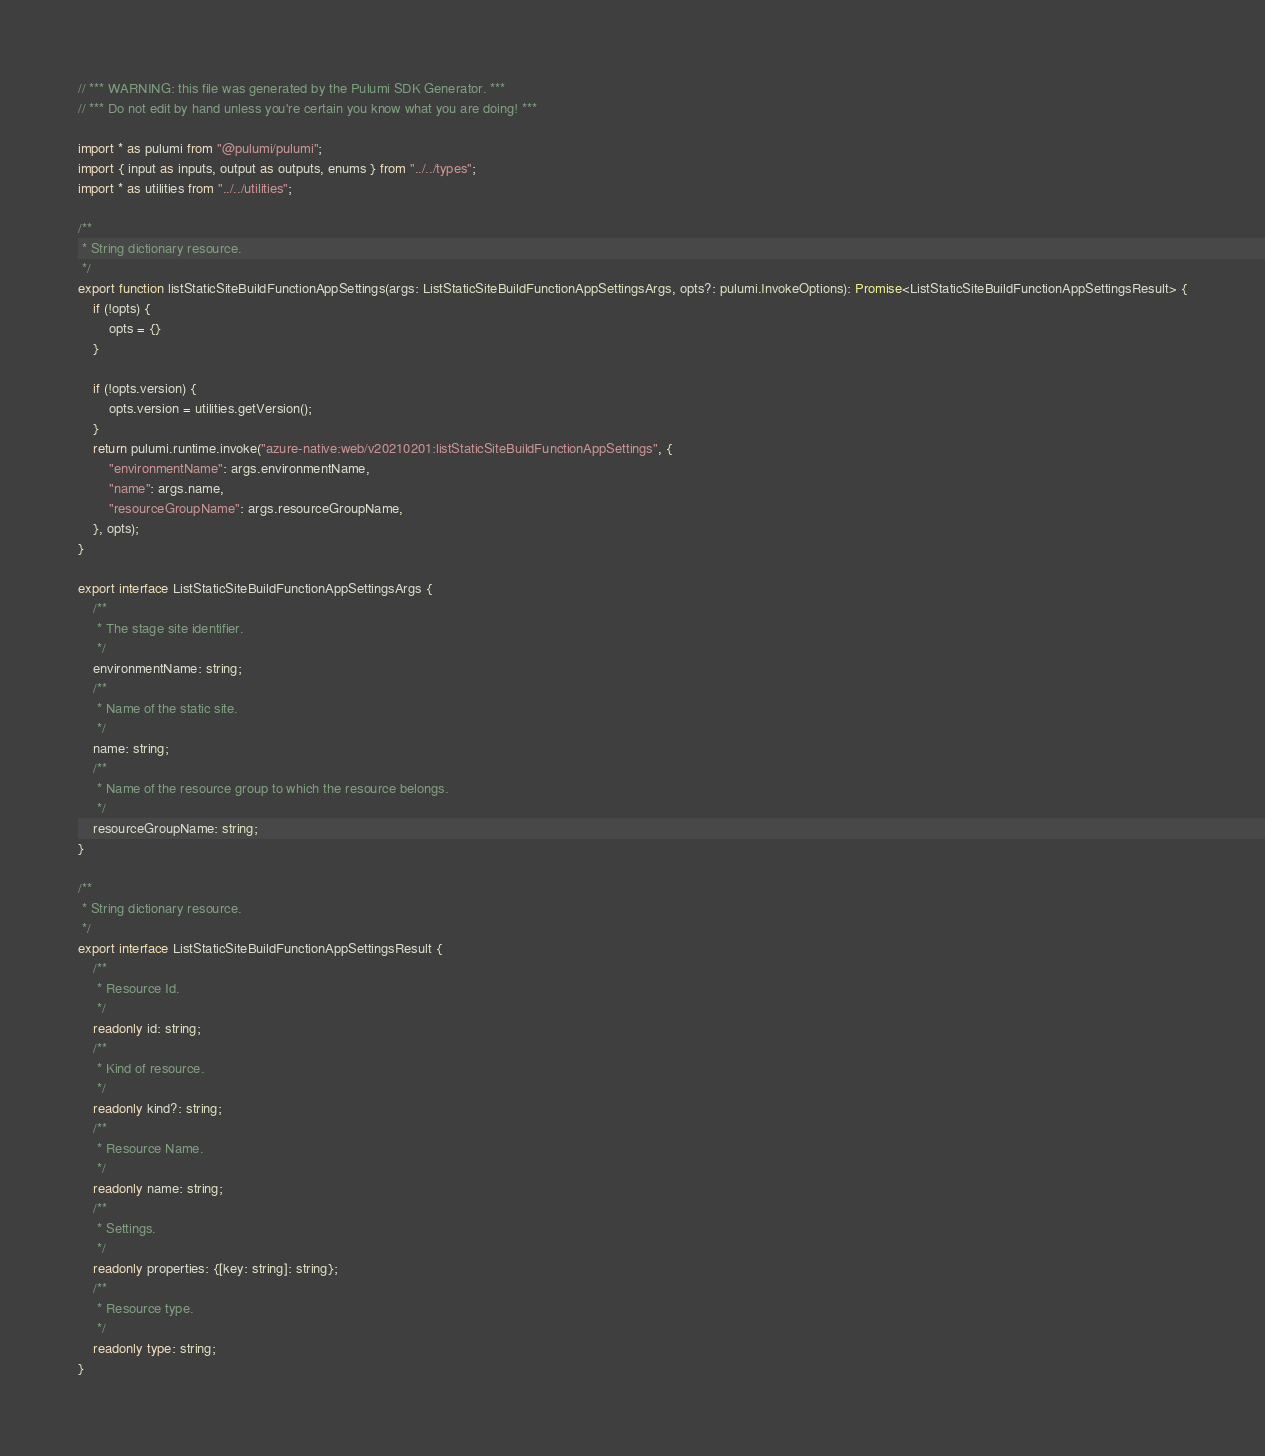Convert code to text. <code><loc_0><loc_0><loc_500><loc_500><_TypeScript_>// *** WARNING: this file was generated by the Pulumi SDK Generator. ***
// *** Do not edit by hand unless you're certain you know what you are doing! ***

import * as pulumi from "@pulumi/pulumi";
import { input as inputs, output as outputs, enums } from "../../types";
import * as utilities from "../../utilities";

/**
 * String dictionary resource.
 */
export function listStaticSiteBuildFunctionAppSettings(args: ListStaticSiteBuildFunctionAppSettingsArgs, opts?: pulumi.InvokeOptions): Promise<ListStaticSiteBuildFunctionAppSettingsResult> {
    if (!opts) {
        opts = {}
    }

    if (!opts.version) {
        opts.version = utilities.getVersion();
    }
    return pulumi.runtime.invoke("azure-native:web/v20210201:listStaticSiteBuildFunctionAppSettings", {
        "environmentName": args.environmentName,
        "name": args.name,
        "resourceGroupName": args.resourceGroupName,
    }, opts);
}

export interface ListStaticSiteBuildFunctionAppSettingsArgs {
    /**
     * The stage site identifier.
     */
    environmentName: string;
    /**
     * Name of the static site.
     */
    name: string;
    /**
     * Name of the resource group to which the resource belongs.
     */
    resourceGroupName: string;
}

/**
 * String dictionary resource.
 */
export interface ListStaticSiteBuildFunctionAppSettingsResult {
    /**
     * Resource Id.
     */
    readonly id: string;
    /**
     * Kind of resource.
     */
    readonly kind?: string;
    /**
     * Resource Name.
     */
    readonly name: string;
    /**
     * Settings.
     */
    readonly properties: {[key: string]: string};
    /**
     * Resource type.
     */
    readonly type: string;
}
</code> 